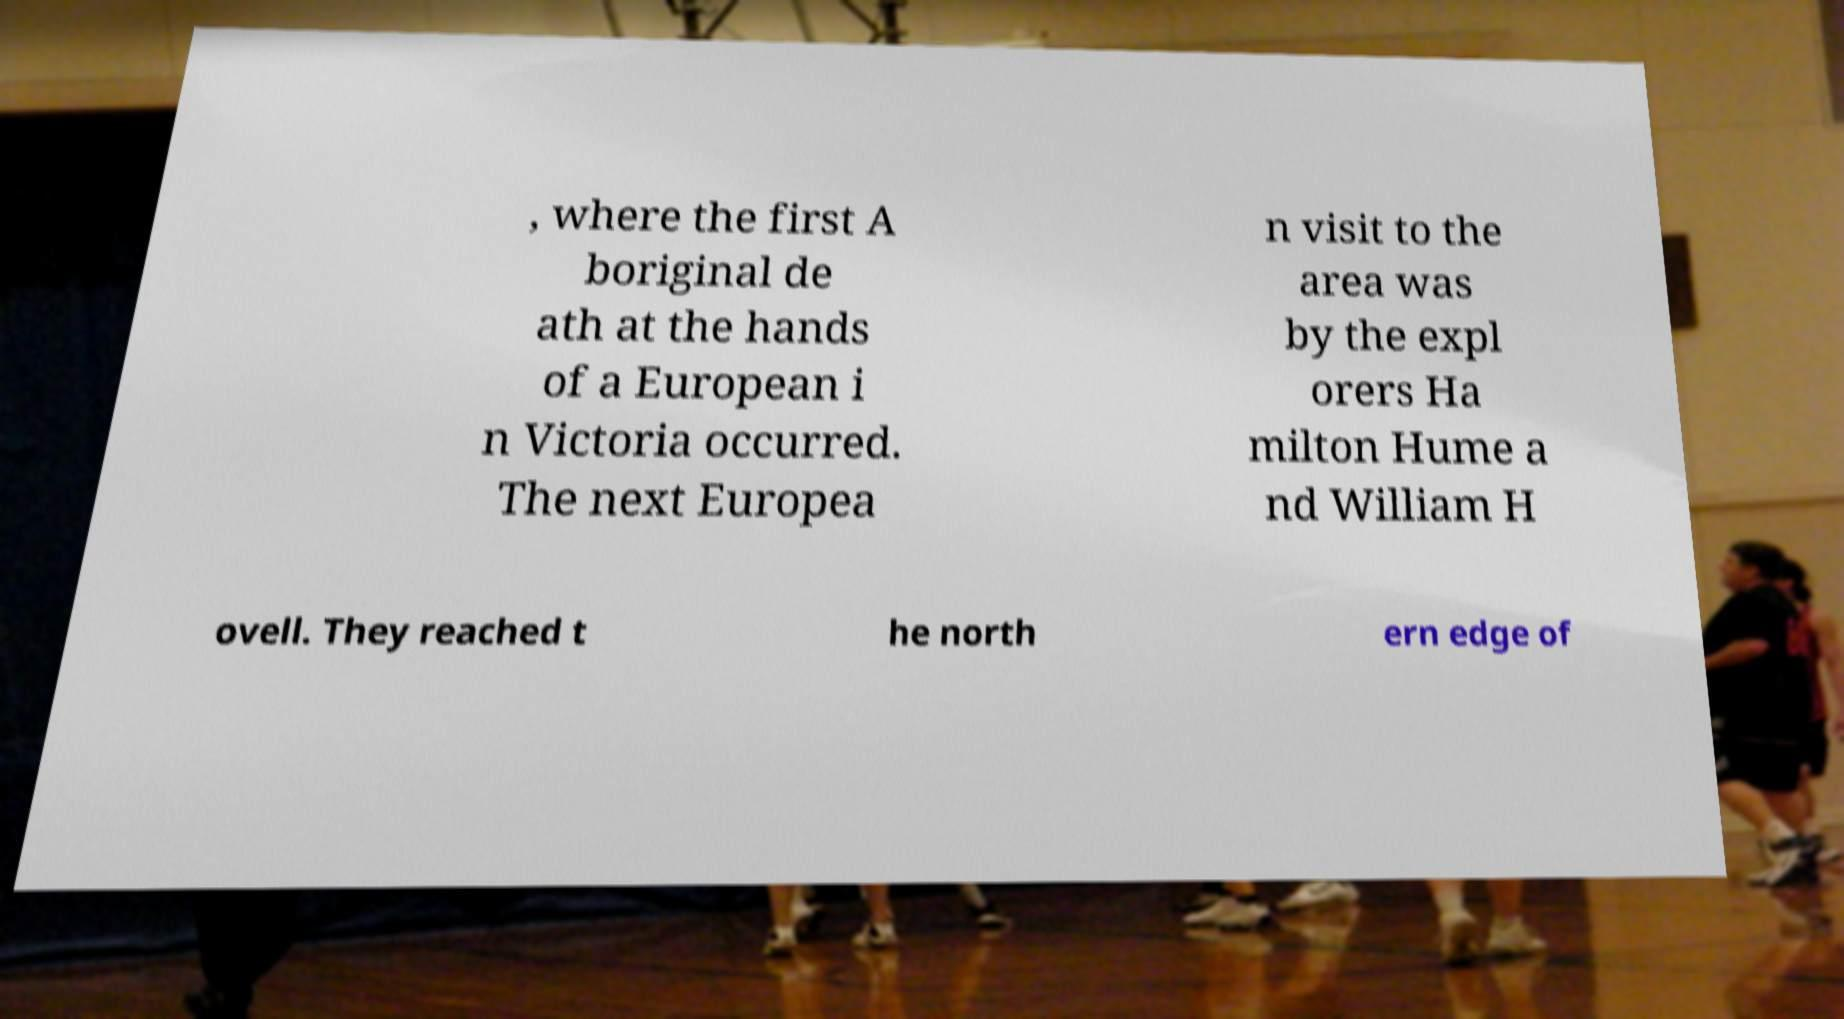Could you extract and type out the text from this image? , where the first A boriginal de ath at the hands of a European i n Victoria occurred. The next Europea n visit to the area was by the expl orers Ha milton Hume a nd William H ovell. They reached t he north ern edge of 